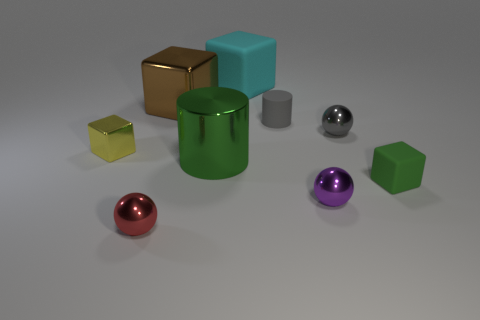Is the number of tiny metal blocks that are behind the tiny gray sphere less than the number of tiny gray cubes?
Provide a succinct answer. No. There is a cylinder that is left of the matte cylinder; what material is it?
Your response must be concise. Metal. What number of other objects are the same size as the cyan matte object?
Ensure brevity in your answer.  2. Is the number of tiny purple metallic cylinders less than the number of tiny purple metal objects?
Your answer should be compact. Yes. There is a purple object; what shape is it?
Ensure brevity in your answer.  Sphere. Do the large thing to the right of the large cylinder and the matte cylinder have the same color?
Offer a terse response. No. What shape is the thing that is both behind the yellow shiny object and in front of the matte cylinder?
Provide a short and direct response. Sphere. There is a small ball to the left of the big cylinder; what color is it?
Your answer should be compact. Red. Is there anything else of the same color as the big metallic cylinder?
Make the answer very short. Yes. Do the gray shiny ball and the purple metallic ball have the same size?
Your response must be concise. Yes. 